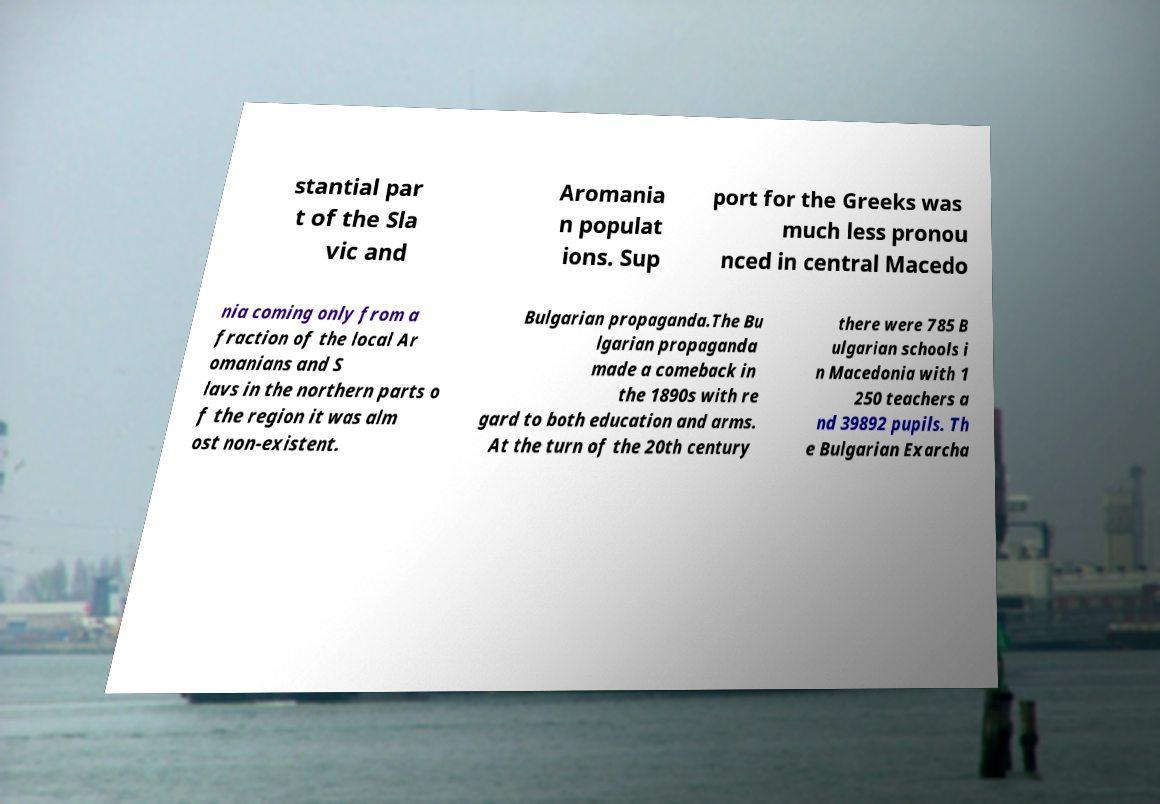For documentation purposes, I need the text within this image transcribed. Could you provide that? stantial par t of the Sla vic and Aromania n populat ions. Sup port for the Greeks was much less pronou nced in central Macedo nia coming only from a fraction of the local Ar omanians and S lavs in the northern parts o f the region it was alm ost non-existent. Bulgarian propaganda.The Bu lgarian propaganda made a comeback in the 1890s with re gard to both education and arms. At the turn of the 20th century there were 785 B ulgarian schools i n Macedonia with 1 250 teachers a nd 39892 pupils. Th e Bulgarian Exarcha 